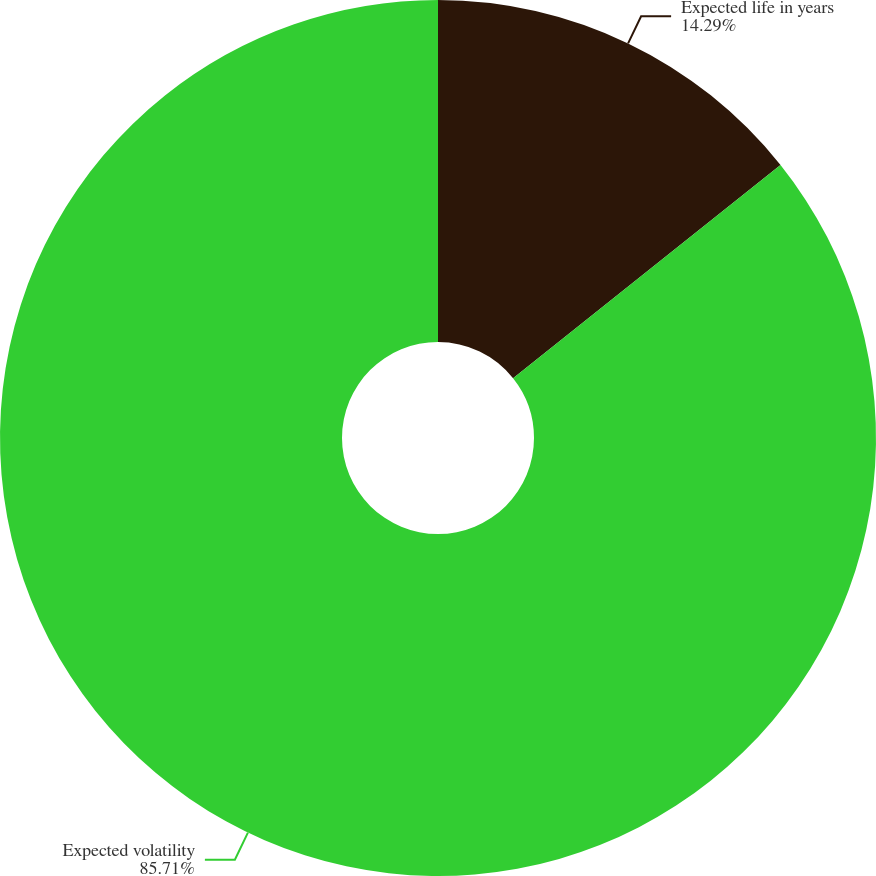Convert chart to OTSL. <chart><loc_0><loc_0><loc_500><loc_500><pie_chart><fcel>Expected life in years<fcel>Expected volatility<nl><fcel>14.29%<fcel>85.71%<nl></chart> 